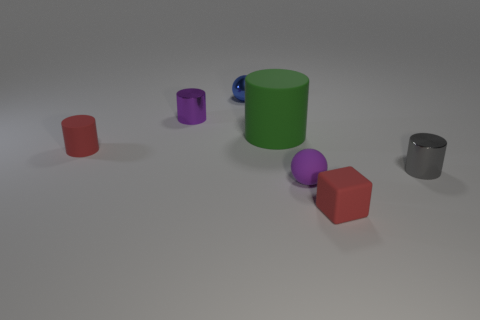How many purple things are either tiny rubber cylinders or rubber things? There is one purple item in the image that meets the criteria of being a rubber thing, specifically a tiny rubber cylinder. 